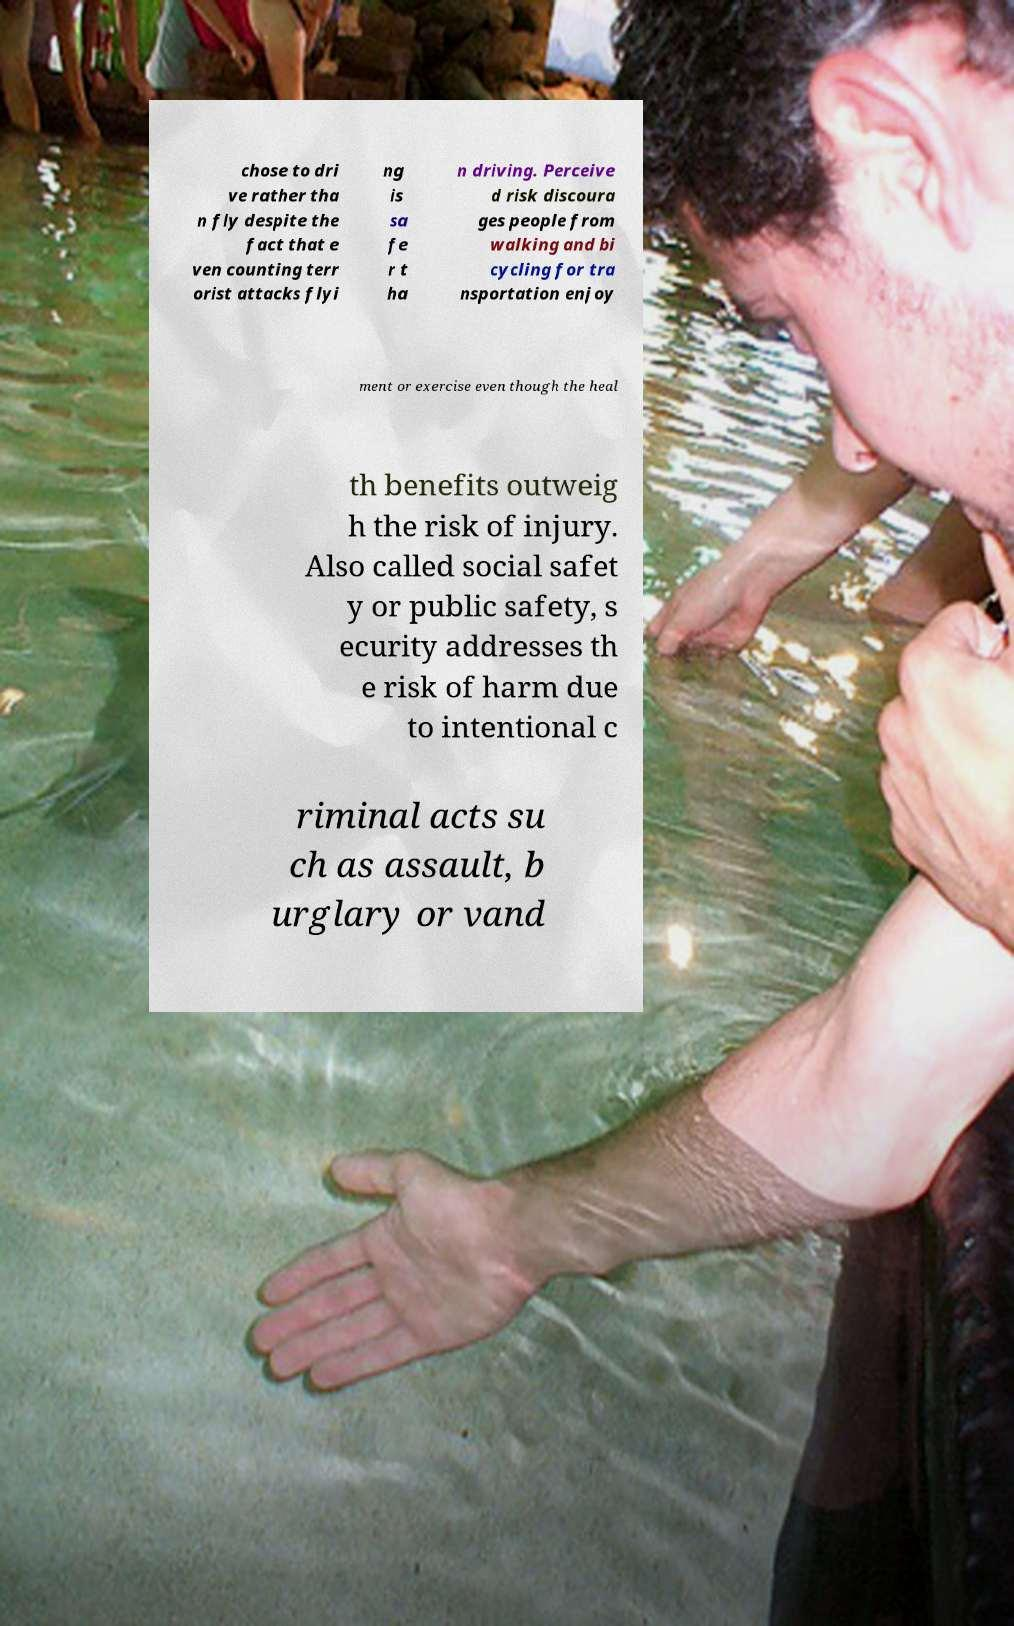Please read and relay the text visible in this image. What does it say? chose to dri ve rather tha n fly despite the fact that e ven counting terr orist attacks flyi ng is sa fe r t ha n driving. Perceive d risk discoura ges people from walking and bi cycling for tra nsportation enjoy ment or exercise even though the heal th benefits outweig h the risk of injury. Also called social safet y or public safety, s ecurity addresses th e risk of harm due to intentional c riminal acts su ch as assault, b urglary or vand 